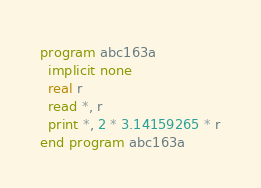<code> <loc_0><loc_0><loc_500><loc_500><_FORTRAN_>program abc163a
  implicit none
  real r
  read *, r
  print *, 2 * 3.14159265 * r
end program abc163a
</code> 